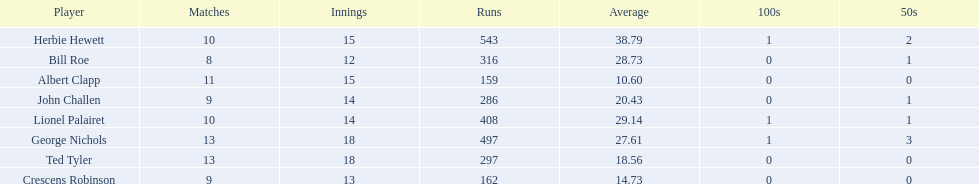Who are all of the players? Herbie Hewett, Lionel Palairet, Bill Roe, George Nichols, John Challen, Ted Tyler, Crescens Robinson, Albert Clapp. How many innings did they play in? 15, 14, 12, 18, 14, 18, 13, 15. Which player was in fewer than 13 innings? Bill Roe. 